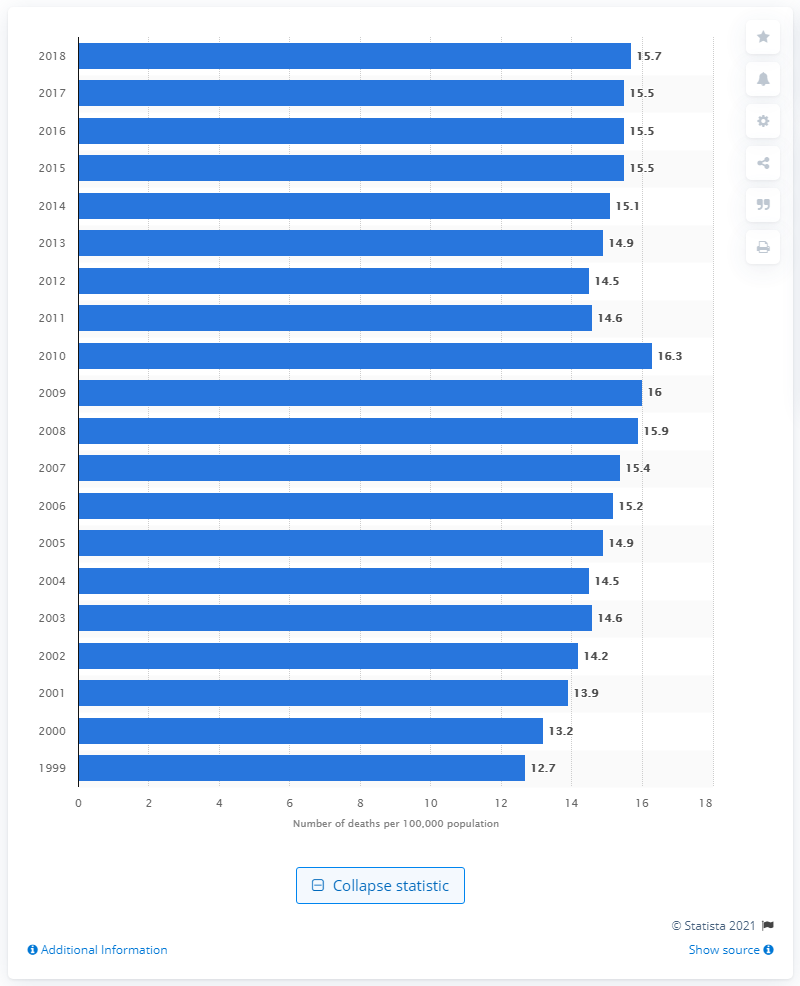Highlight a few significant elements in this photo. In the given year, there were X number of deaths from nephritis, nephrotic syndrome, and nephrosis per 100,000 people. 